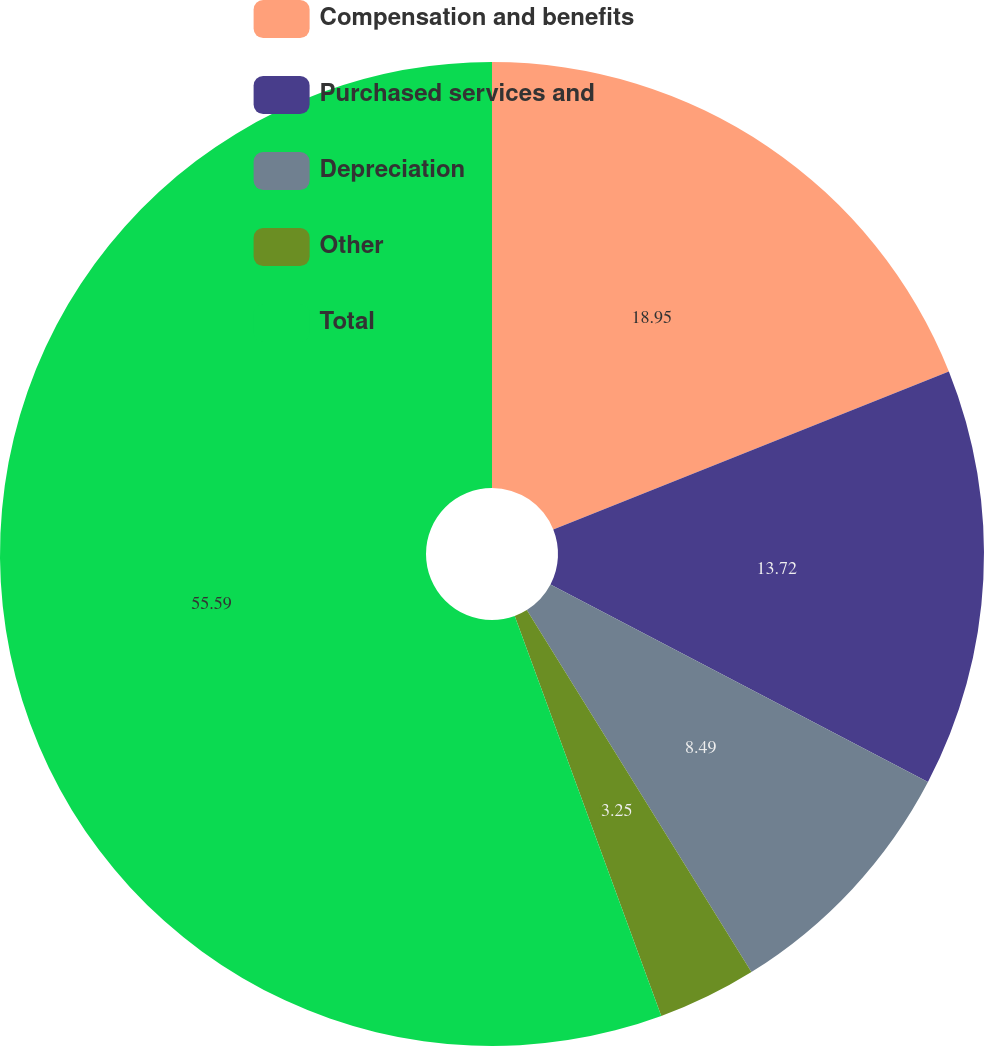Convert chart. <chart><loc_0><loc_0><loc_500><loc_500><pie_chart><fcel>Compensation and benefits<fcel>Purchased services and<fcel>Depreciation<fcel>Other<fcel>Total<nl><fcel>18.95%<fcel>13.72%<fcel>8.49%<fcel>3.25%<fcel>55.59%<nl></chart> 